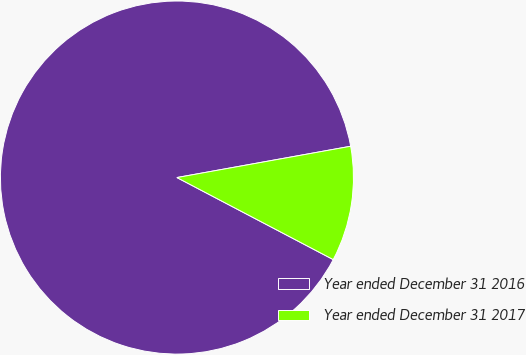<chart> <loc_0><loc_0><loc_500><loc_500><pie_chart><fcel>Year ended December 31 2016<fcel>Year ended December 31 2017<nl><fcel>89.47%<fcel>10.53%<nl></chart> 